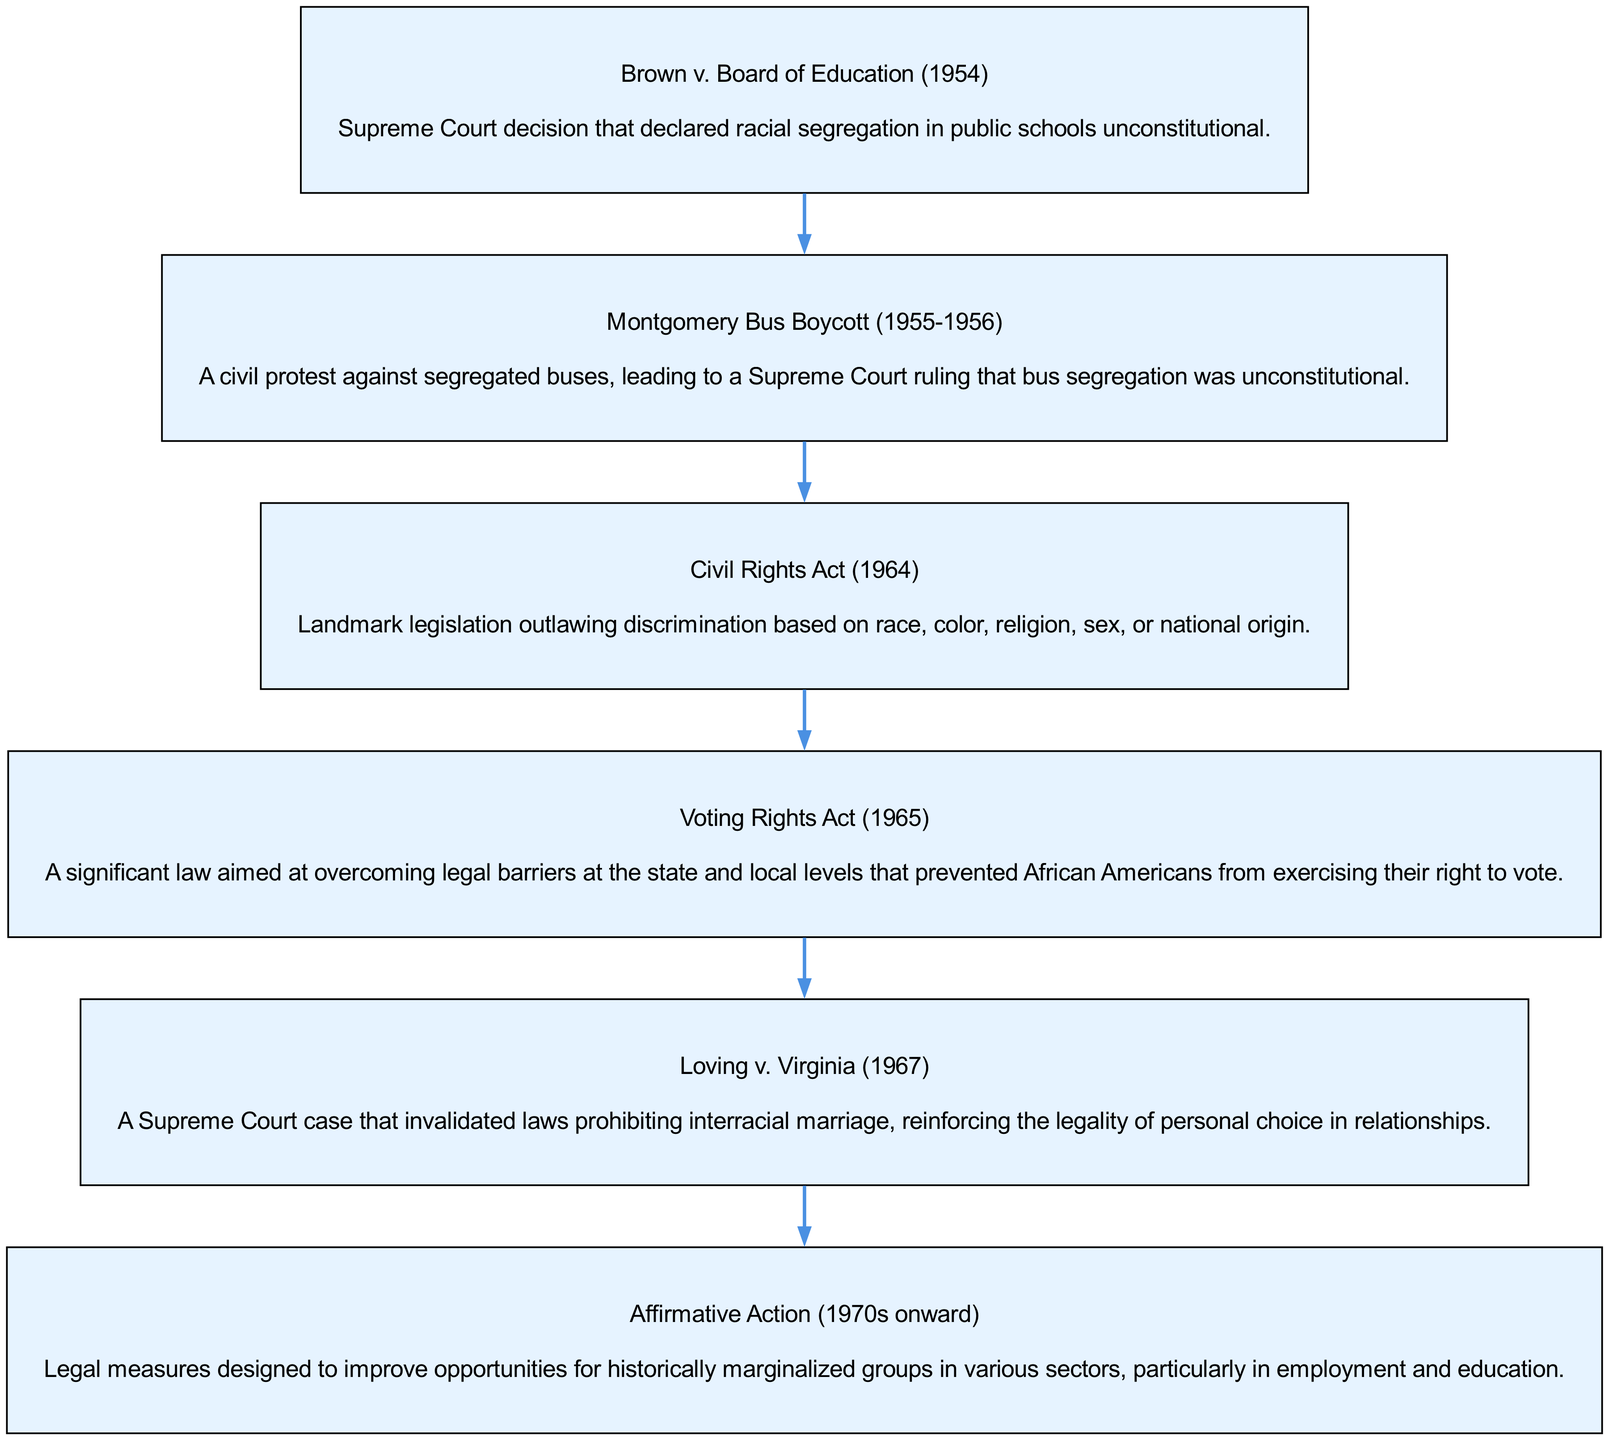What is the title of the first step in the diagram? The first step is labeled "Brown v. Board of Education (1954)" as it is the first node in the flow chart, indicating the starting point of the Civil Rights Movement timeline.
Answer: Brown v. Board of Education (1954) How many steps are presented in the diagram? The diagram includes a total of six distinct steps, each representing a significant event or legislation in the Civil Rights Movement, indicated by six nodes.
Answer: 6 What was the outcome of the Montgomery Bus Boycott? The description linked to the Montgomery Bus Boycott states it led to a Supreme Court ruling that declared bus segregation unconstitutional, illustrating its legal significance.
Answer: Unconstitutional Which step comes immediately after the Civil Rights Act? By following the flow of the diagram, the step immediately following the Civil Rights Act (1964) is the Voting Rights Act (1965), connected by an edge indicating the chronological order.
Answer: Voting Rights Act (1965) What is the primary legal focus of the Voting Rights Act? The Voting Rights Act is described as a significant law aimed at overcoming legal barriers preventing African Americans from voting, highlighting its objective in a legal context.
Answer: Voting rights How did the Loving v. Virginia case impact laws against interracial marriage? According to the diagram, the Loving v. Virginia case invalidated laws prohibiting interracial marriage, reinforcing the legal acknowledgment of personal choice in relationships, indicating a significant change in law and policy.
Answer: Invalidated laws prohibiting interracial marriage What types of groups were targeted by Affirmative Action policies? The flow chart informs that Affirmative Action measures were designed to improve opportunities for historically marginalized groups, emphasizing the target demographic for these legal measures.
Answer: Historically marginalized groups 